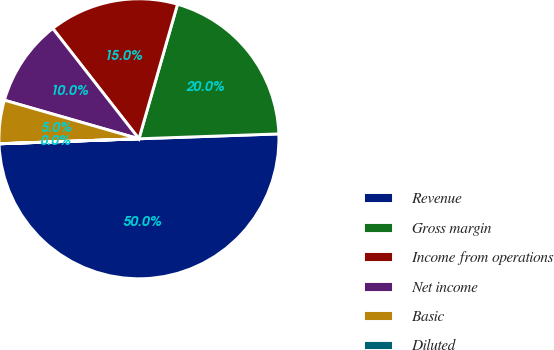Convert chart. <chart><loc_0><loc_0><loc_500><loc_500><pie_chart><fcel>Revenue<fcel>Gross margin<fcel>Income from operations<fcel>Net income<fcel>Basic<fcel>Diluted<nl><fcel>49.98%<fcel>20.0%<fcel>15.0%<fcel>10.0%<fcel>5.01%<fcel>0.01%<nl></chart> 